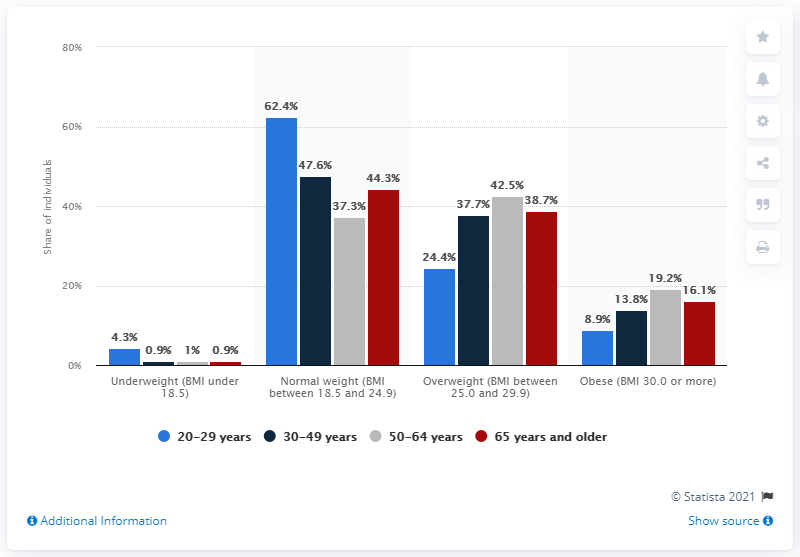Give some essential details in this illustration. In the age group of 50 to 64 years old, the highest share of obese individuals in Sweden was 19.2%. In the age group of 50 to 64 years old in Sweden, only 37.3% of individuals were of normal weight. According to the given data, there is a significant difference between normal weight and obese individuals in the age range of 20-29 years, with the normal weight group having a higher mean BMI at 23.1 and the obese group having a mean BMI of 28.7. The age group with the highest share was 20-29 years old. In 2020, the share of normal weight individuals in Sweden was 62.4%. 